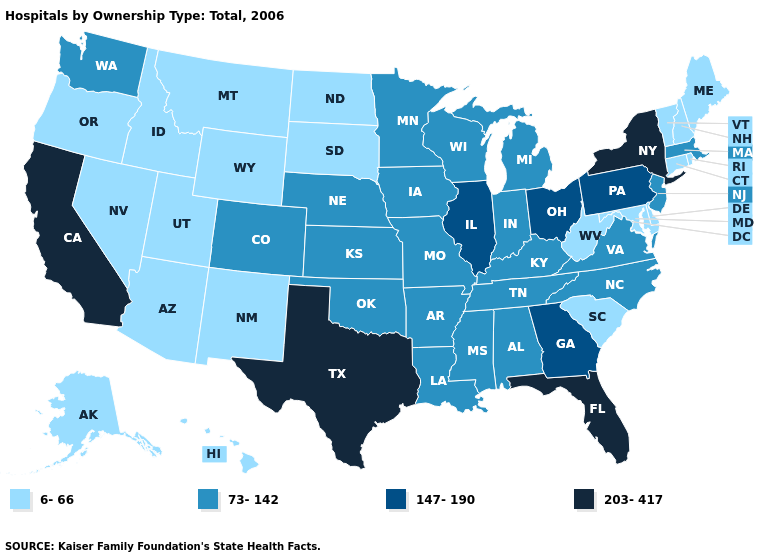Does the first symbol in the legend represent the smallest category?
Be succinct. Yes. What is the value of Arizona?
Concise answer only. 6-66. What is the lowest value in the South?
Keep it brief. 6-66. Does the map have missing data?
Be succinct. No. Name the states that have a value in the range 203-417?
Concise answer only. California, Florida, New York, Texas. What is the value of North Carolina?
Answer briefly. 73-142. Does Ohio have the highest value in the MidWest?
Concise answer only. Yes. Which states have the highest value in the USA?
Be succinct. California, Florida, New York, Texas. Does Kentucky have the lowest value in the South?
Write a very short answer. No. What is the highest value in the MidWest ?
Concise answer only. 147-190. How many symbols are there in the legend?
Be succinct. 4. What is the lowest value in the MidWest?
Write a very short answer. 6-66. What is the value of North Dakota?
Give a very brief answer. 6-66. Name the states that have a value in the range 147-190?
Write a very short answer. Georgia, Illinois, Ohio, Pennsylvania. Which states have the lowest value in the West?
Quick response, please. Alaska, Arizona, Hawaii, Idaho, Montana, Nevada, New Mexico, Oregon, Utah, Wyoming. 